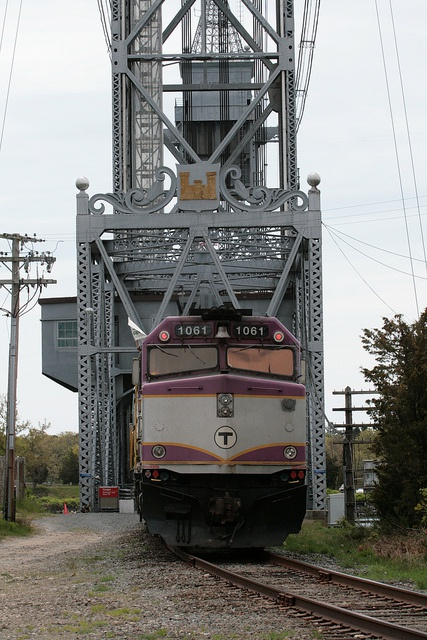Describe the objects in this image and their specific colors. I can see a train in white, black, and gray tones in this image. 